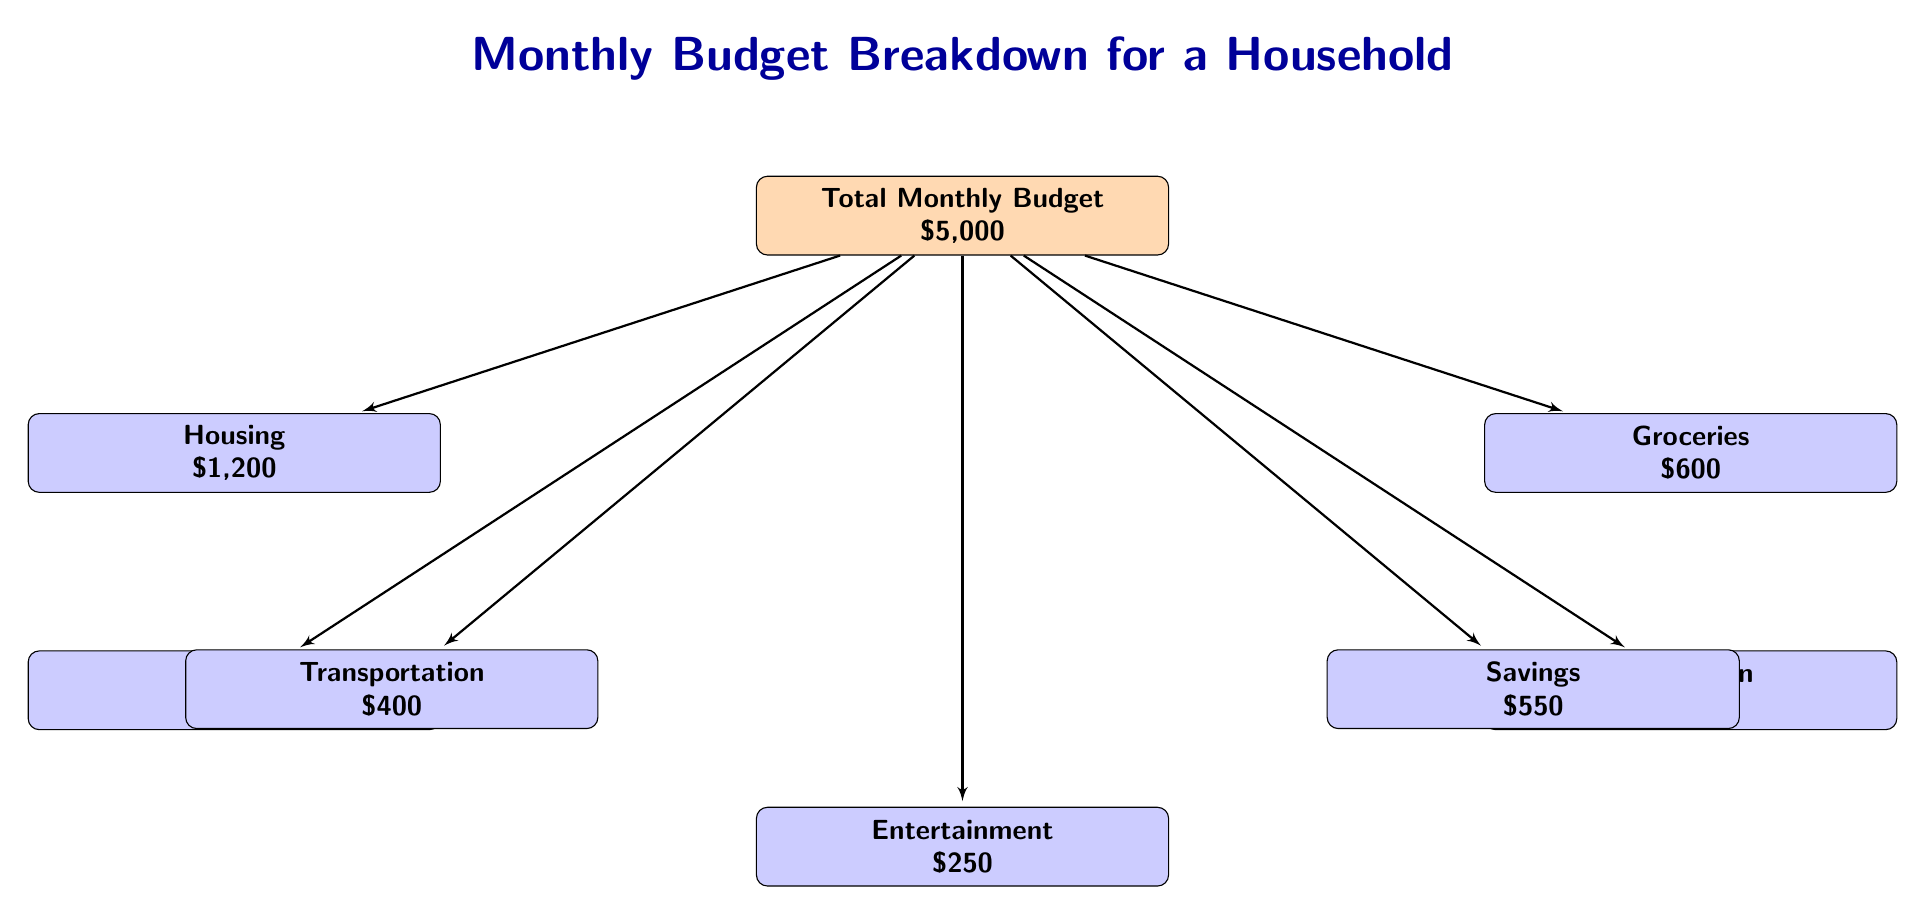What is the total monthly budget for the household? The total monthly budget is presented at the top center of the diagram. It clearly states that the amount is $5,000.
Answer: $5,000 How much is allocated for housing? The housing expense is indicated in the diagram, positioned below the main budget node. It shows that $1,200 is allocated for this category.
Answer: $1,200 What category has the highest expense? By comparing the values of each category listed in the diagram, the highest expense is found to be education, which is $700.
Answer: Education How many categories are shown in the diagram? To determine the total number of categories, we count each of the six distinct expense categories presented: housing, utilities, groceries, education, transportation, entertainment, and savings. This totals to seven categories.
Answer: 7 What is the combined total of utilities and entertainment? First, we identify the values for utilities, which is $300, and entertainment, which is $250. Then we sum the two values: $300 + $250 = $550.
Answer: $550 What is the difference between savings and transportation expenses? The savings amount is $550, and the transportation expense is $400. To find the difference, we subtract transportation from savings: $550 - $400 = $150.
Answer: $150 Which category receives the least amount? By analyzing the expense categories and their respective allocations, it can be observed that entertainment has the least amount allocated at $250.
Answer: Entertainment What percentage of the total budget is spent on groceries? First, we recognize that groceries are allocated $600 from the total budget of $5,000. To find the percentage, we calculate: (600 / 5000) * 100 = 12%.
Answer: 12% 